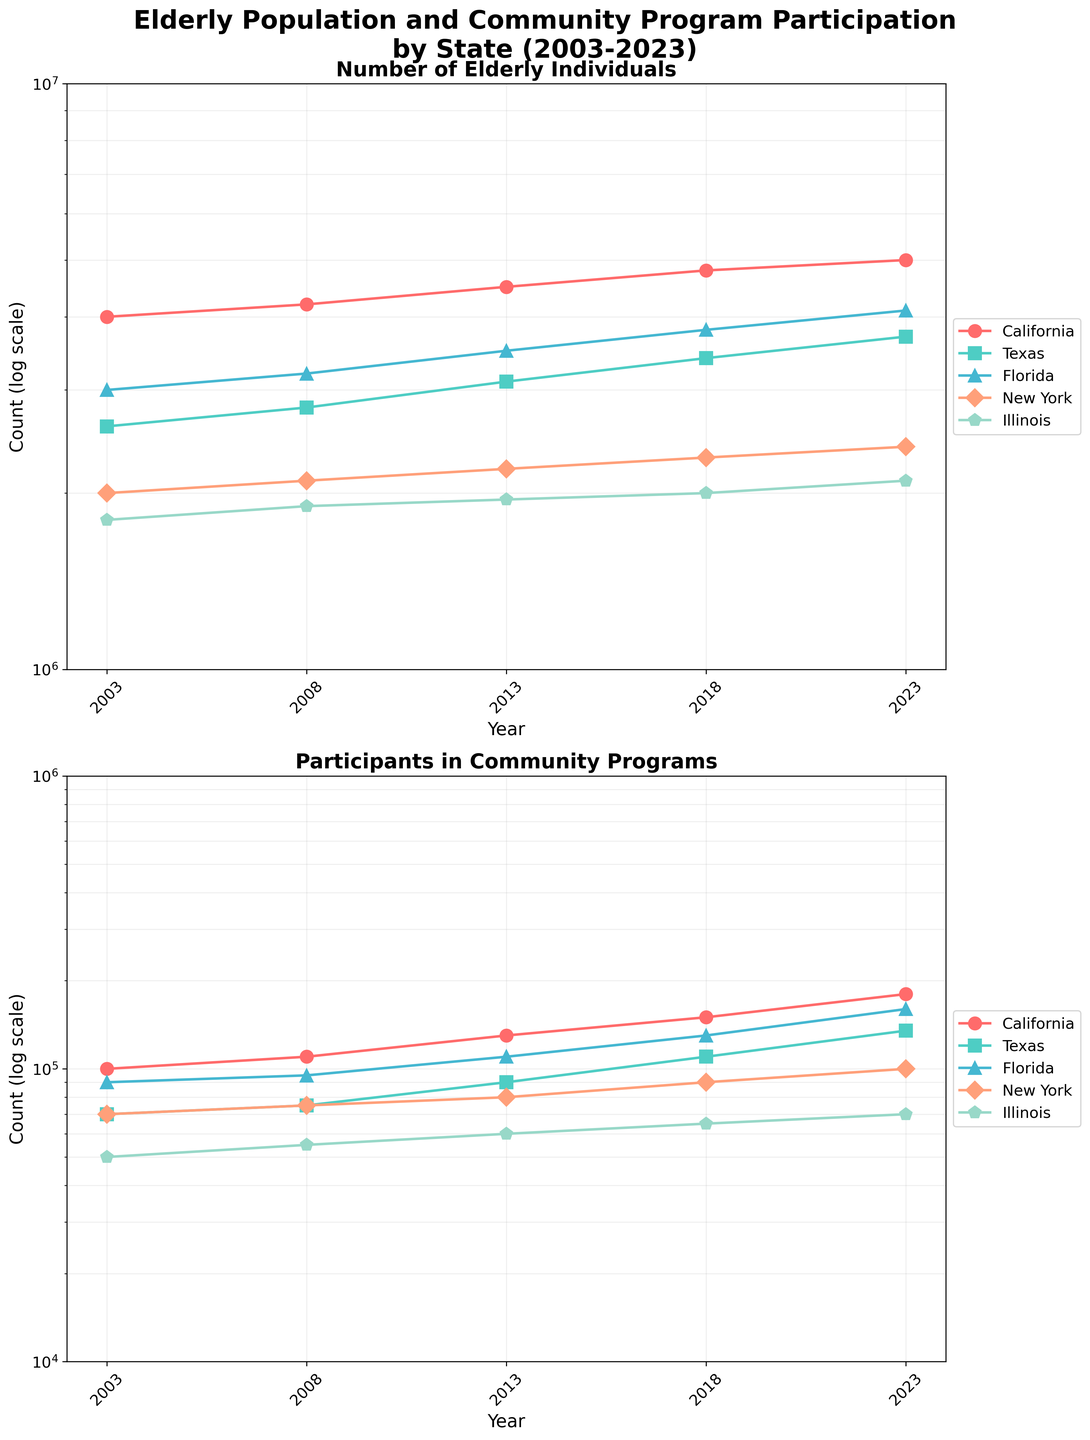What is the title of the figure? The title is at the top of the figure, and it reads "Elderly Population and Community Program Participation by State (2003-2023)".
Answer: Elderly Population and Community Program Participation by State (2003-2023) What is the scale used for the y-axis in both subplots? Both subplots use a logarithmic (log) scale for the y-axis, evident from the labeling style and the mention in the y-axis title ("log scale").
Answer: Logarithmic scale Which state has the highest number of elderly individuals in 2023? The top subplot "Number of Elderly Individuals" shows that California has the highest count in 2023, as indicated by the highest point at the rightmost side of the graph.
Answer: California Between which years did Florida's participation in community programs increase the most? In the bottom subplot, the largest vertical jump for Florida's data (represented by one of the specified colors and markers) appears between 2018 and 2023.
Answer: 2018-2023 How many states are represented in the plots? There are five different colors and markers in both subplots, representing the five states listed in the data table: California, Texas, Florida, New York, and Illinois.
Answer: Five Which state shows the least number of participants in community programs in 2003? In the bottom subplot, Illinois shows the lowest point in 2003, confirming it as the state with the least number of participants in that year.
Answer: Illinois What is the difference in the number of elderly individuals between Texas and New York in 2018? From the "Number of Elderly Individuals" subplot, in 2018, Texas has around 3,400,000 elderly individuals and New York has around 2,300,000. The difference is 3,400,000 - 2,300,000 = 1,100,000.
Answer: 1,100,000 What is the growth rate of participants in community programs in California from 2018 to 2023? For California, in the bottom subplot, the values are approximately 150,000 in 2018 and 180,000 in 2023. Growth rate = ((180,000 - 150,000) / 150,000) * 100% = 20%.
Answer: 20% Does Illinois show a steady increase in the number of elderly individuals over the 20 years? Observing the "Number of Elderly Individuals" subplot, Illinois' trend line steadily increases without any dips or dramatic rises, indicating a consistent growth.
Answer: Yes 